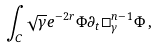<formula> <loc_0><loc_0><loc_500><loc_500>\int _ { C } \sqrt { \gamma } e ^ { - 2 r } \Phi \partial _ { t } \square ^ { n - 1 } _ { \gamma } \Phi \, ,</formula> 